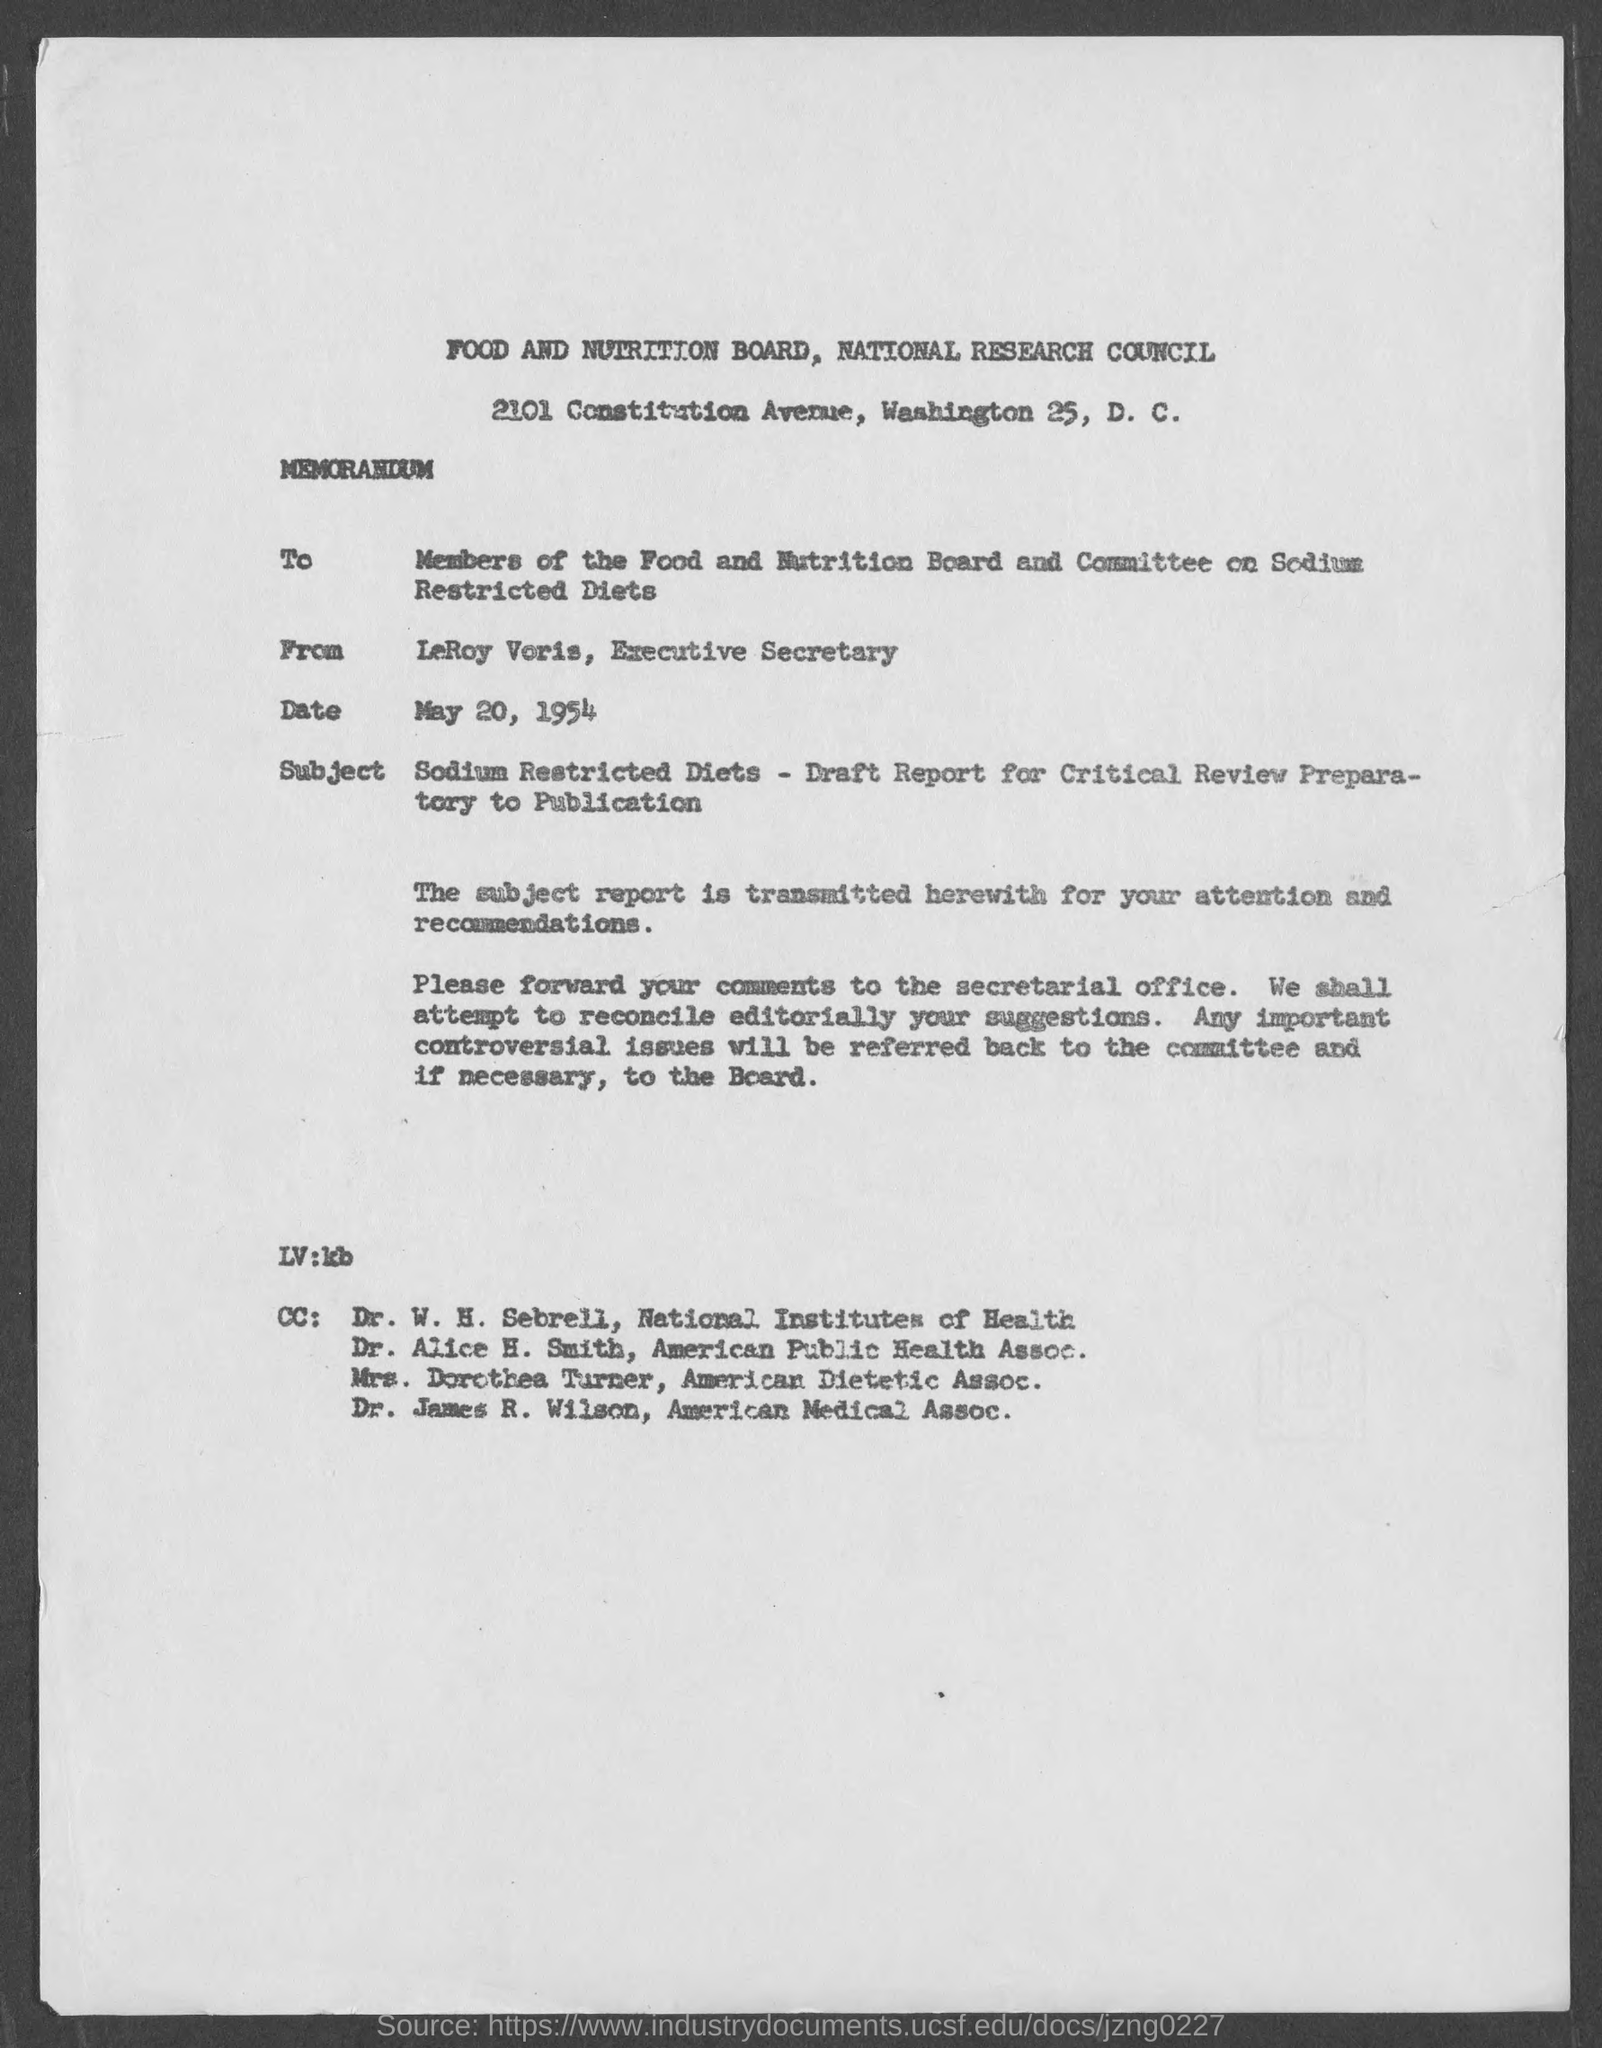What is the from address in memorandum ?
Your answer should be compact. LeRoy Voris, Executive Secretary. What is the position of leroy voris?
Offer a terse response. Executive Secretary. When is the memorandum dated?
Ensure brevity in your answer.  May 20, 1954. To which institute does dr. w.h. sebrell belong ?
Keep it short and to the point. National Institutes of Health. To which association does dr. alice h. smith belong?
Provide a short and direct response. American Public Health Assoc. To which association does mrs. dorothea turner belong ?
Provide a succinct answer. American Dietetic Assoc. To which association does dr. james r. wilson belong?
Provide a short and direct response. American Medical Assoc. 